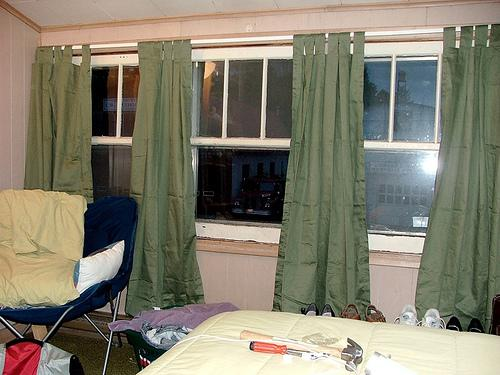What time of day is it likely to be? Please explain your reasoning. evening. It's nighttime as it's dark. 